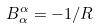Convert formula to latex. <formula><loc_0><loc_0><loc_500><loc_500>B _ { \alpha } ^ { \alpha } = - 1 / R</formula> 